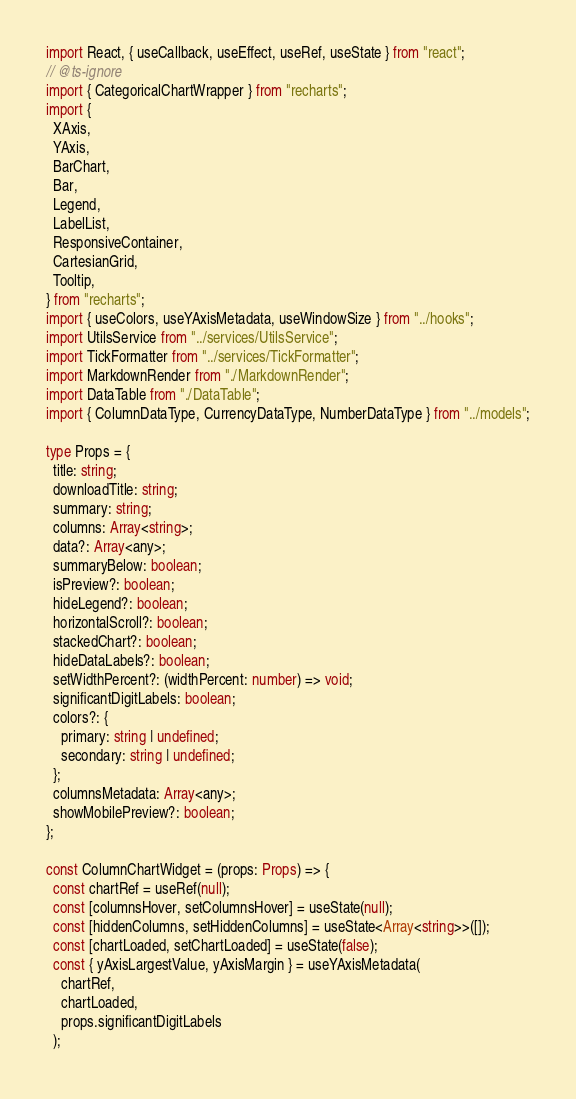Convert code to text. <code><loc_0><loc_0><loc_500><loc_500><_TypeScript_>import React, { useCallback, useEffect, useRef, useState } from "react";
// @ts-ignore
import { CategoricalChartWrapper } from "recharts";
import {
  XAxis,
  YAxis,
  BarChart,
  Bar,
  Legend,
  LabelList,
  ResponsiveContainer,
  CartesianGrid,
  Tooltip,
} from "recharts";
import { useColors, useYAxisMetadata, useWindowSize } from "../hooks";
import UtilsService from "../services/UtilsService";
import TickFormatter from "../services/TickFormatter";
import MarkdownRender from "./MarkdownRender";
import DataTable from "./DataTable";
import { ColumnDataType, CurrencyDataType, NumberDataType } from "../models";

type Props = {
  title: string;
  downloadTitle: string;
  summary: string;
  columns: Array<string>;
  data?: Array<any>;
  summaryBelow: boolean;
  isPreview?: boolean;
  hideLegend?: boolean;
  horizontalScroll?: boolean;
  stackedChart?: boolean;
  hideDataLabels?: boolean;
  setWidthPercent?: (widthPercent: number) => void;
  significantDigitLabels: boolean;
  colors?: {
    primary: string | undefined;
    secondary: string | undefined;
  };
  columnsMetadata: Array<any>;
  showMobilePreview?: boolean;
};

const ColumnChartWidget = (props: Props) => {
  const chartRef = useRef(null);
  const [columnsHover, setColumnsHover] = useState(null);
  const [hiddenColumns, setHiddenColumns] = useState<Array<string>>([]);
  const [chartLoaded, setChartLoaded] = useState(false);
  const { yAxisLargestValue, yAxisMargin } = useYAxisMetadata(
    chartRef,
    chartLoaded,
    props.significantDigitLabels
  );
</code> 